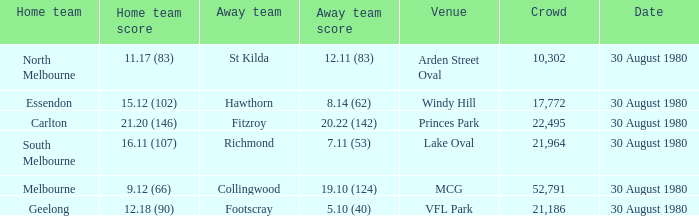What was the score for south melbourne at home? 16.11 (107). 